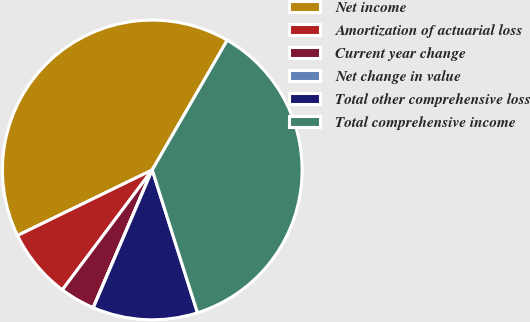Convert chart to OTSL. <chart><loc_0><loc_0><loc_500><loc_500><pie_chart><fcel>Net income<fcel>Amortization of actuarial loss<fcel>Current year change<fcel>Net change in value<fcel>Total other comprehensive loss<fcel>Total comprehensive income<nl><fcel>40.55%<fcel>7.55%<fcel>3.79%<fcel>0.02%<fcel>11.31%<fcel>36.78%<nl></chart> 